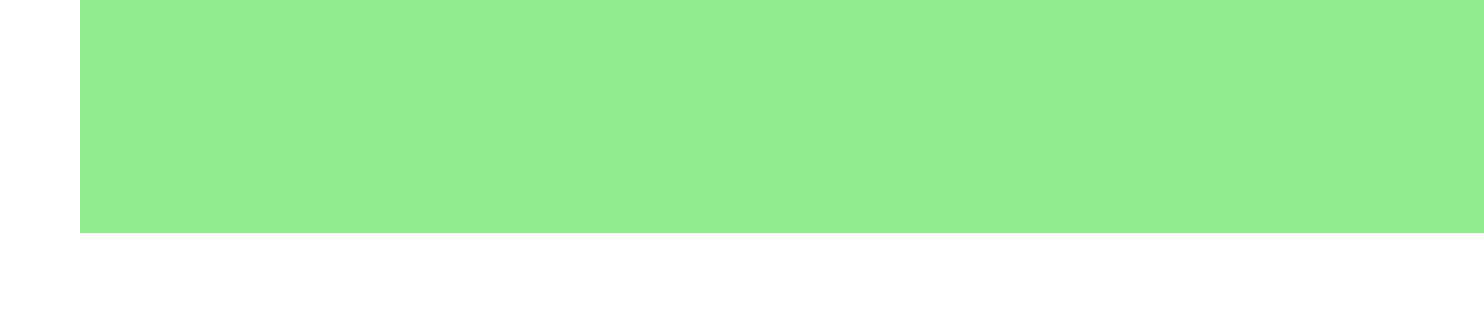What is the transaction ID? The transaction ID is found at the top of the document, identifying this specific transaction record.
Answer: CO-2023-05-15-001 Who is the buyer? The buyer's name is explicitly mentioned in the transaction details section of the document.
Answer: Dr. Emma Greenwood What is the total amount for the carbon credits? The total amount is listed under the payment information section, summarizing the cost of the carbon credits purchased.
Answer: 578.75 USD How many carbon credits were purchased for the Amazon Rainforest Conservation Project? The quantity of credits for this specific project is stated within the table of carbon credits.
Answer: 25 What is the certification standard mentioned in the document? The certification standard is provided in the certification section, indicating the quality of the carbon offset credits.
Answer: Gold Standard What is the purpose of travel to Manaus, Brazil? The document states the purpose of travel in the travel details section, providing insight into the research being conducted.
Answer: Field research on deforestation impact on local river ecosystems Which company sold the carbon credits? The seller's name is mentioned in the transaction details, identifying the company involved in the sale.
Answer: Carbon Offset Solutions Inc What kind of travel was used for the study on wind farm installations? The mode of transportation used for this travel is listed under the travel details section, indicating how the researcher traveled.
Answer: Air travel How many credits were purchased for the Gansu Wind Farm Project? The quantity for this project is mentioned in the table detailing the carbon credits, providing a clear count of credits acquired.
Answer: 15 